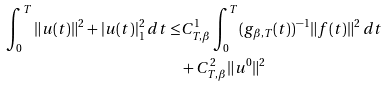Convert formula to latex. <formula><loc_0><loc_0><loc_500><loc_500>\int _ { 0 } ^ { T } \| u ( t ) \| ^ { 2 } + | u ( t ) | _ { 1 } ^ { 2 } \, d t \leq & C ^ { 1 } _ { T , \beta } \int _ { 0 } ^ { T } ( g _ { \beta , T } ( t ) ) ^ { - 1 } \| f ( t ) \| ^ { 2 } \, d t \\ & + C ^ { 2 } _ { T , \beta } \| u ^ { 0 } \| ^ { 2 }</formula> 